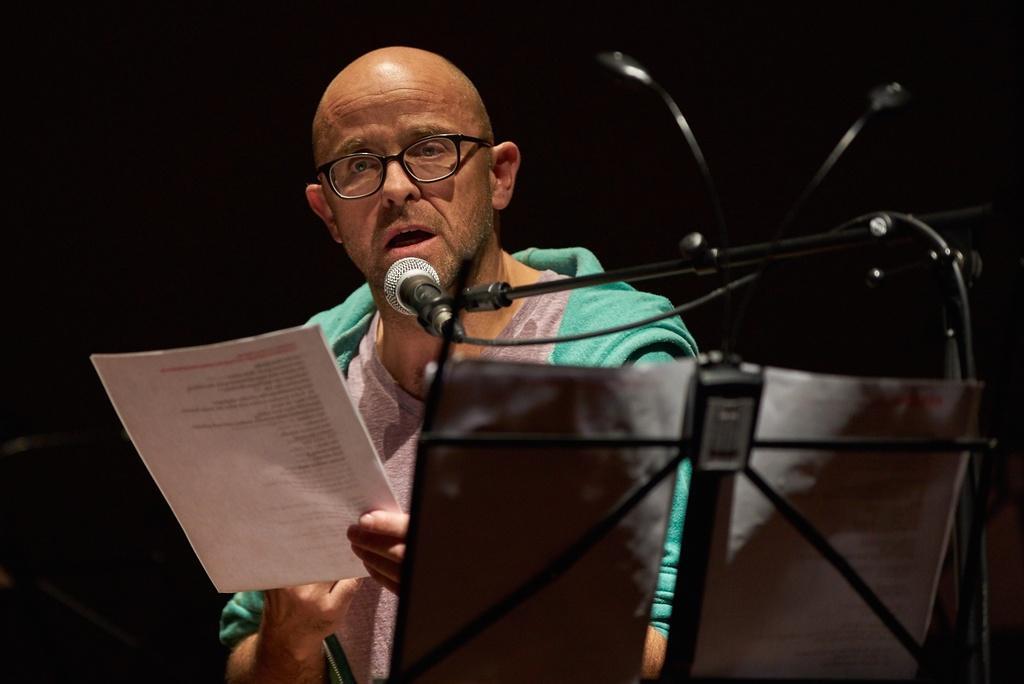Could you give a brief overview of what you see in this image? In this image I can see the person with the dress and holding the paper. In-front of the person I can see the black color stand. On the stand I can the mic and papers. 